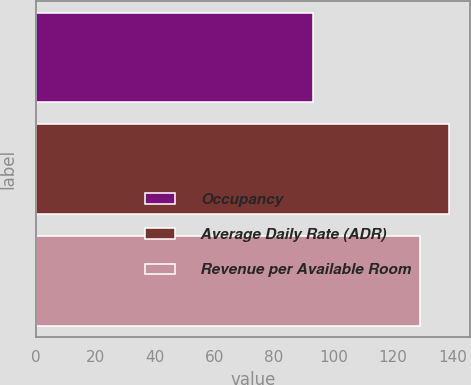<chart> <loc_0><loc_0><loc_500><loc_500><bar_chart><fcel>Occupancy<fcel>Average Daily Rate (ADR)<fcel>Revenue per Available Room<nl><fcel>93<fcel>139<fcel>129<nl></chart> 